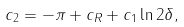Convert formula to latex. <formula><loc_0><loc_0><loc_500><loc_500>c _ { 2 } = - \pi + c _ { R } + c _ { 1 } \ln 2 \delta ,</formula> 